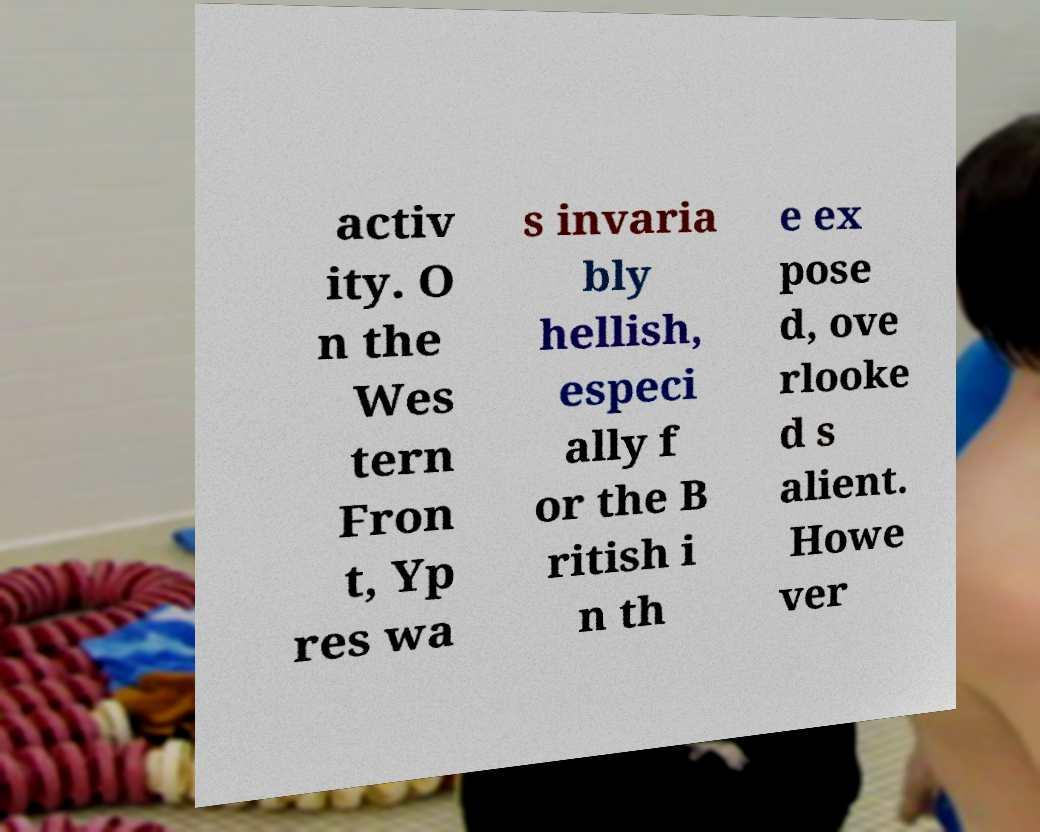Can you read and provide the text displayed in the image?This photo seems to have some interesting text. Can you extract and type it out for me? activ ity. O n the Wes tern Fron t, Yp res wa s invaria bly hellish, especi ally f or the B ritish i n th e ex pose d, ove rlooke d s alient. Howe ver 